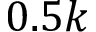<formula> <loc_0><loc_0><loc_500><loc_500>0 . 5 k</formula> 